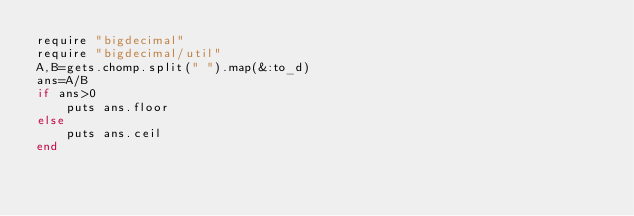Convert code to text. <code><loc_0><loc_0><loc_500><loc_500><_Ruby_>require "bigdecimal"
require "bigdecimal/util"
A,B=gets.chomp.split(" ").map(&:to_d)
ans=A/B
if ans>0
    puts ans.floor
else
    puts ans.ceil
end
</code> 